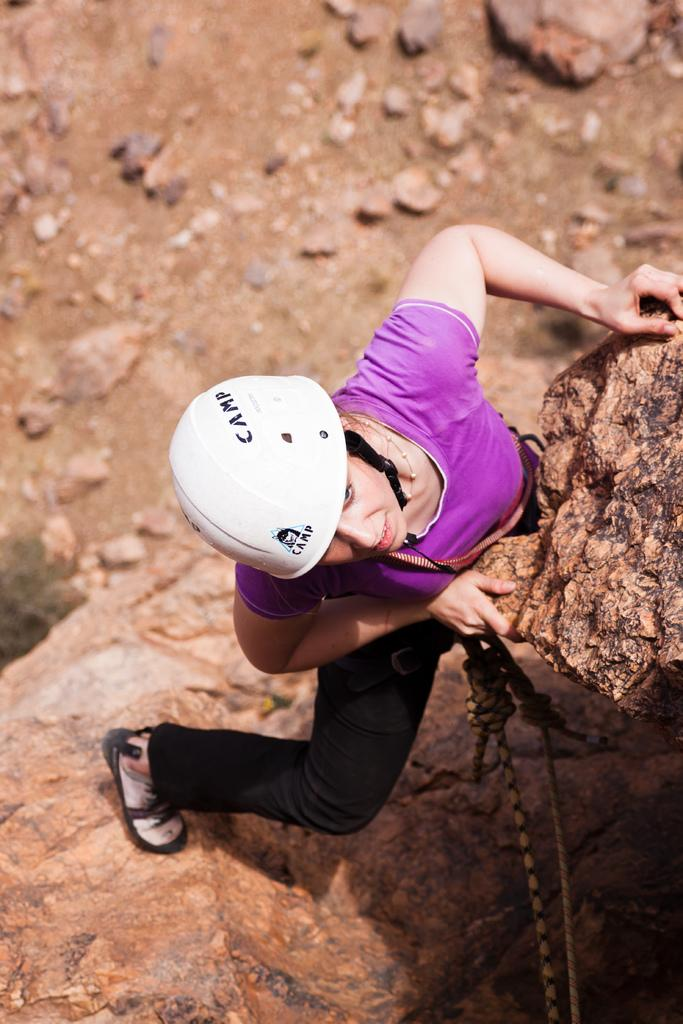What type of natural formation can be seen in the image? There are big rocks in the image. Who is present in the image? There is a woman in the image. What is the woman wearing on her head? The woman is wearing a white helmet. What is connected to the woman in the image? The woman has two wires attached to her. What activity is the woman engaged in? The woman is sport climbing. What type of frame is the woman holding in the image? There is no frame present in the image; the woman is sport climbing with wires attached to her. What type of plate is visible on the rocks in the image? There is no plate visible on the rocks in the image; it is a natural formation with big rocks. 